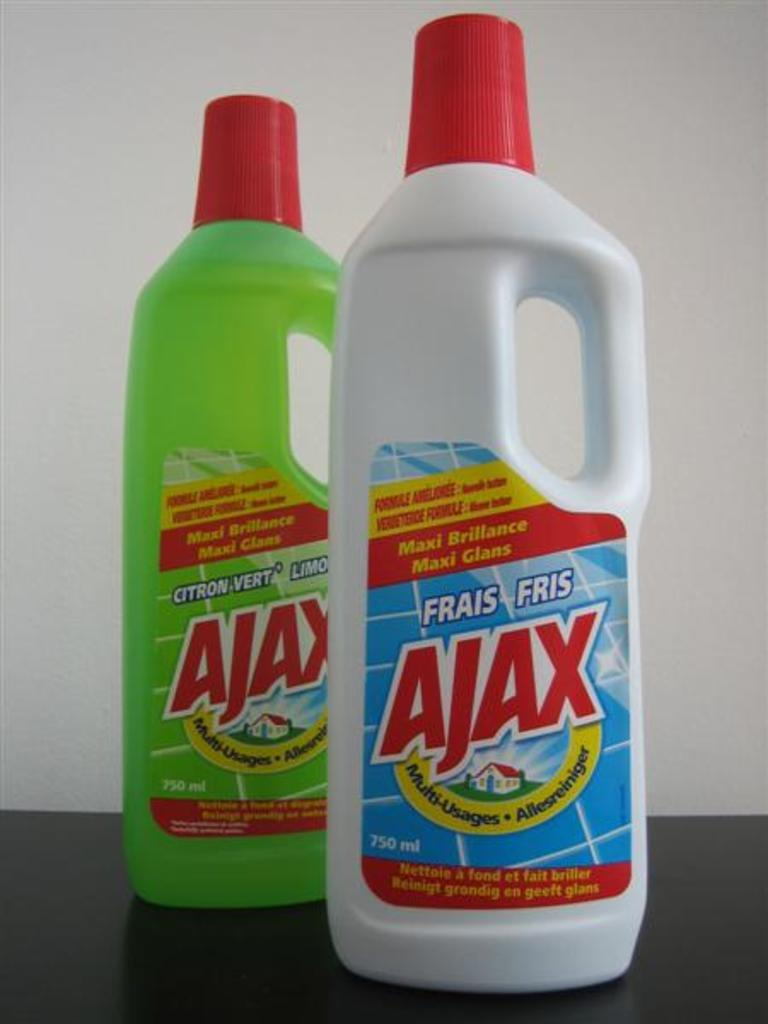Provide a one-sentence caption for the provided image. Two bottles of liquid used for cleaning by a brand called Ajax. 